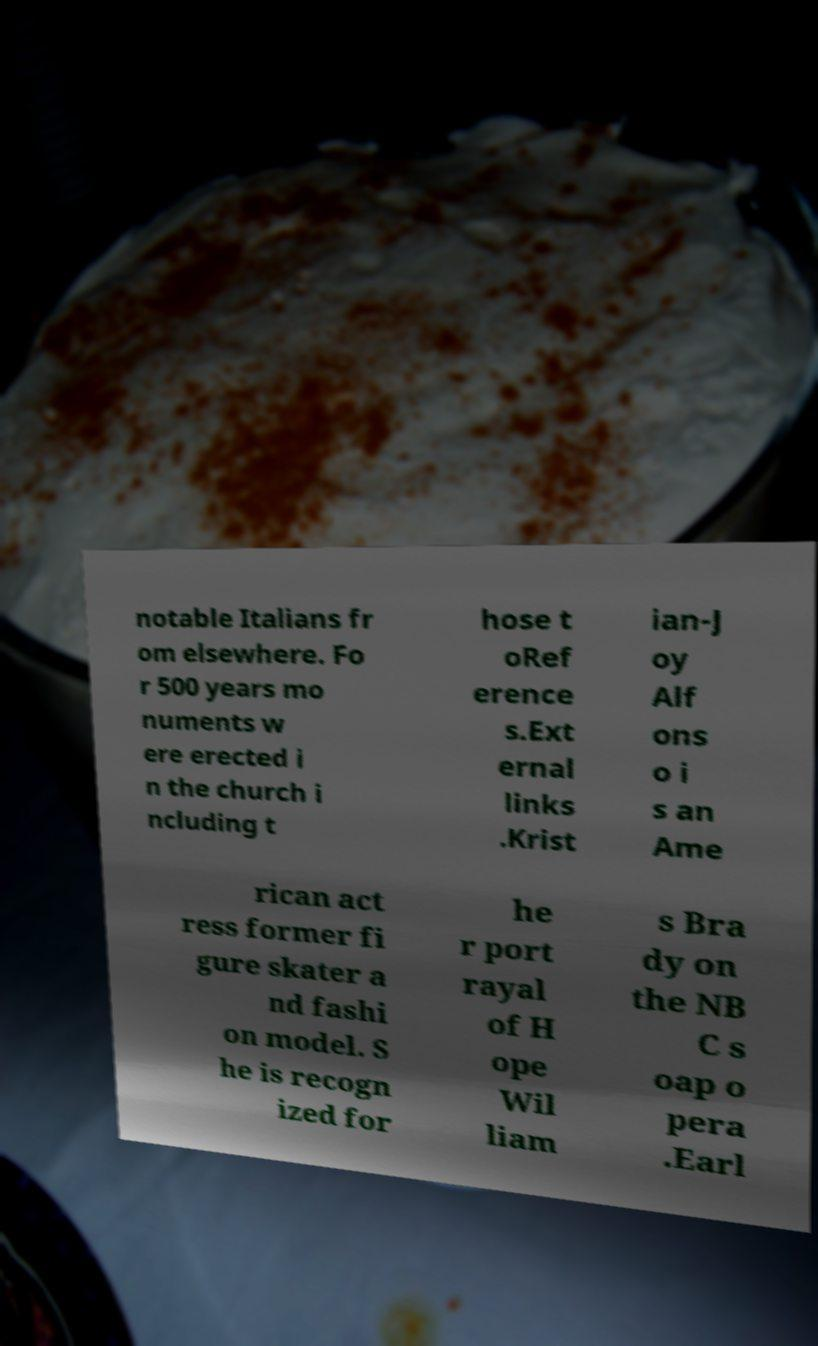What messages or text are displayed in this image? I need them in a readable, typed format. notable Italians fr om elsewhere. Fo r 500 years mo numents w ere erected i n the church i ncluding t hose t oRef erence s.Ext ernal links .Krist ian-J oy Alf ons o i s an Ame rican act ress former fi gure skater a nd fashi on model. S he is recogn ized for he r port rayal of H ope Wil liam s Bra dy on the NB C s oap o pera .Earl 